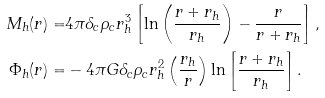Convert formula to latex. <formula><loc_0><loc_0><loc_500><loc_500>M _ { h } ( r ) = & 4 \pi \delta _ { c } \rho _ { c } r _ { h } ^ { 3 } \left [ \ln \left ( \frac { r + r _ { h } } { r _ { h } } \right ) - \frac { r } { r + r _ { h } } \right ] , \\ \Phi _ { h } ( r ) = & - 4 \pi G \delta _ { c } \rho _ { c } r _ { h } ^ { 2 } \left ( \frac { r _ { h } } { r } \right ) \ln \left [ \frac { r + r _ { h } } { r _ { h } } \right ] .</formula> 